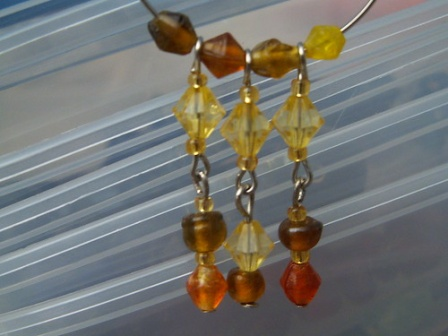Imagine you could wear these earrings to a fantastical event. Describe the event. Imagine wearing these earrings to a grand masquerade ball held in a glittering palace floating above the clouds. The palace is adorned with sparkling crystals and vibrant flowers, with floating lanterns illuminating the night sky. Guests from different magical realms arrive in luxurious and exotic costumes, each piece radiating an otherworldly charm. The earrings, with their vibrant beads and elegant silver chains, perfectly complement your elaborate gown made of shimmering silk and adorned with tiny, twinkling stars. As you glide through the ball, the earrings catch the light and the attention of the enchanted guests, making you the dazzling focal point of this fantastical night. 